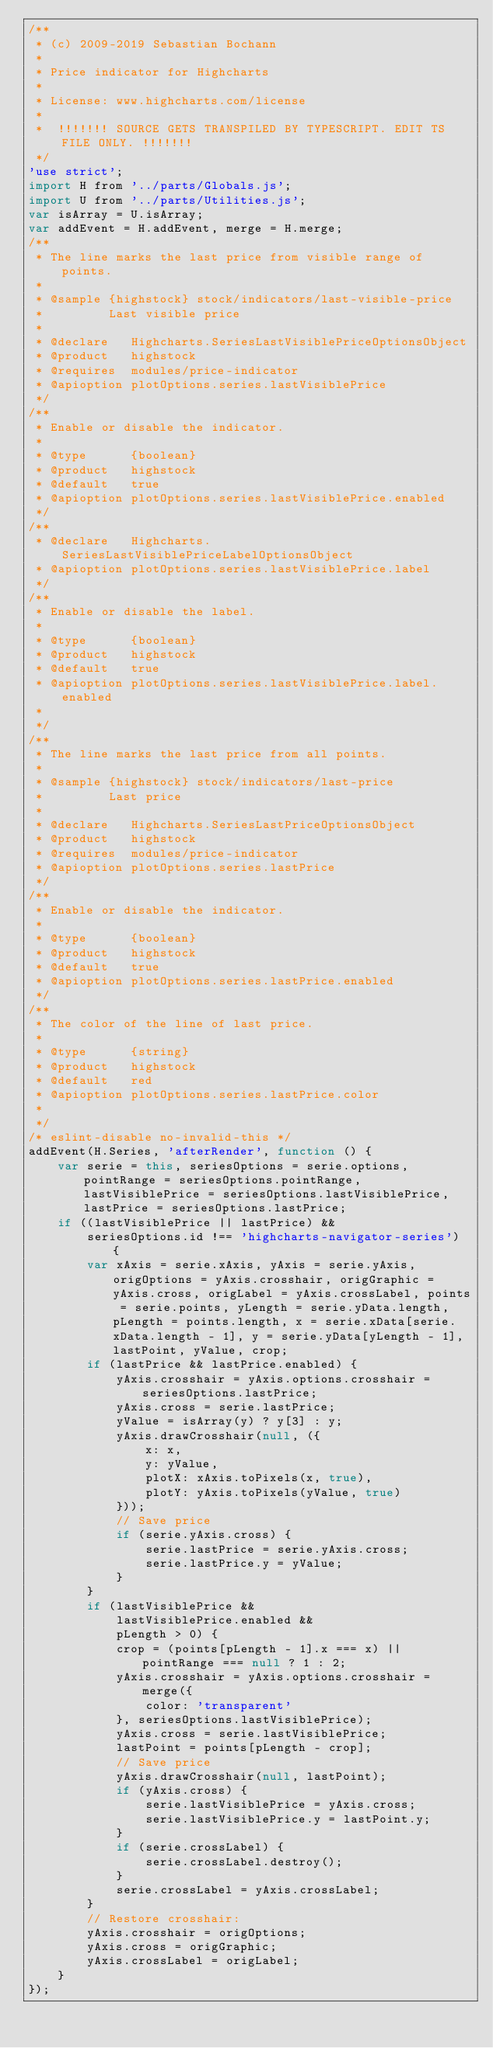<code> <loc_0><loc_0><loc_500><loc_500><_JavaScript_>/**
 * (c) 2009-2019 Sebastian Bochann
 *
 * Price indicator for Highcharts
 *
 * License: www.highcharts.com/license
 *
 *  !!!!!!! SOURCE GETS TRANSPILED BY TYPESCRIPT. EDIT TS FILE ONLY. !!!!!!!
 */
'use strict';
import H from '../parts/Globals.js';
import U from '../parts/Utilities.js';
var isArray = U.isArray;
var addEvent = H.addEvent, merge = H.merge;
/**
 * The line marks the last price from visible range of points.
 *
 * @sample {highstock} stock/indicators/last-visible-price
 *         Last visible price
 *
 * @declare   Highcharts.SeriesLastVisiblePriceOptionsObject
 * @product   highstock
 * @requires  modules/price-indicator
 * @apioption plotOptions.series.lastVisiblePrice
 */
/**
 * Enable or disable the indicator.
 *
 * @type      {boolean}
 * @product   highstock
 * @default   true
 * @apioption plotOptions.series.lastVisiblePrice.enabled
 */
/**
 * @declare   Highcharts.SeriesLastVisiblePriceLabelOptionsObject
 * @apioption plotOptions.series.lastVisiblePrice.label
 */
/**
 * Enable or disable the label.
 *
 * @type      {boolean}
 * @product   highstock
 * @default   true
 * @apioption plotOptions.series.lastVisiblePrice.label.enabled
 *
 */
/**
 * The line marks the last price from all points.
 *
 * @sample {highstock} stock/indicators/last-price
 *         Last price
 *
 * @declare   Highcharts.SeriesLastPriceOptionsObject
 * @product   highstock
 * @requires  modules/price-indicator
 * @apioption plotOptions.series.lastPrice
 */
/**
 * Enable or disable the indicator.
 *
 * @type      {boolean}
 * @product   highstock
 * @default   true
 * @apioption plotOptions.series.lastPrice.enabled
 */
/**
 * The color of the line of last price.
 *
 * @type      {string}
 * @product   highstock
 * @default   red
 * @apioption plotOptions.series.lastPrice.color
 *
 */
/* eslint-disable no-invalid-this */
addEvent(H.Series, 'afterRender', function () {
    var serie = this, seriesOptions = serie.options, pointRange = seriesOptions.pointRange, lastVisiblePrice = seriesOptions.lastVisiblePrice, lastPrice = seriesOptions.lastPrice;
    if ((lastVisiblePrice || lastPrice) &&
        seriesOptions.id !== 'highcharts-navigator-series') {
        var xAxis = serie.xAxis, yAxis = serie.yAxis, origOptions = yAxis.crosshair, origGraphic = yAxis.cross, origLabel = yAxis.crossLabel, points = serie.points, yLength = serie.yData.length, pLength = points.length, x = serie.xData[serie.xData.length - 1], y = serie.yData[yLength - 1], lastPoint, yValue, crop;
        if (lastPrice && lastPrice.enabled) {
            yAxis.crosshair = yAxis.options.crosshair = seriesOptions.lastPrice;
            yAxis.cross = serie.lastPrice;
            yValue = isArray(y) ? y[3] : y;
            yAxis.drawCrosshair(null, ({
                x: x,
                y: yValue,
                plotX: xAxis.toPixels(x, true),
                plotY: yAxis.toPixels(yValue, true)
            }));
            // Save price
            if (serie.yAxis.cross) {
                serie.lastPrice = serie.yAxis.cross;
                serie.lastPrice.y = yValue;
            }
        }
        if (lastVisiblePrice &&
            lastVisiblePrice.enabled &&
            pLength > 0) {
            crop = (points[pLength - 1].x === x) || pointRange === null ? 1 : 2;
            yAxis.crosshair = yAxis.options.crosshair = merge({
                color: 'transparent'
            }, seriesOptions.lastVisiblePrice);
            yAxis.cross = serie.lastVisiblePrice;
            lastPoint = points[pLength - crop];
            // Save price
            yAxis.drawCrosshair(null, lastPoint);
            if (yAxis.cross) {
                serie.lastVisiblePrice = yAxis.cross;
                serie.lastVisiblePrice.y = lastPoint.y;
            }
            if (serie.crossLabel) {
                serie.crossLabel.destroy();
            }
            serie.crossLabel = yAxis.crossLabel;
        }
        // Restore crosshair:
        yAxis.crosshair = origOptions;
        yAxis.cross = origGraphic;
        yAxis.crossLabel = origLabel;
    }
});
</code> 